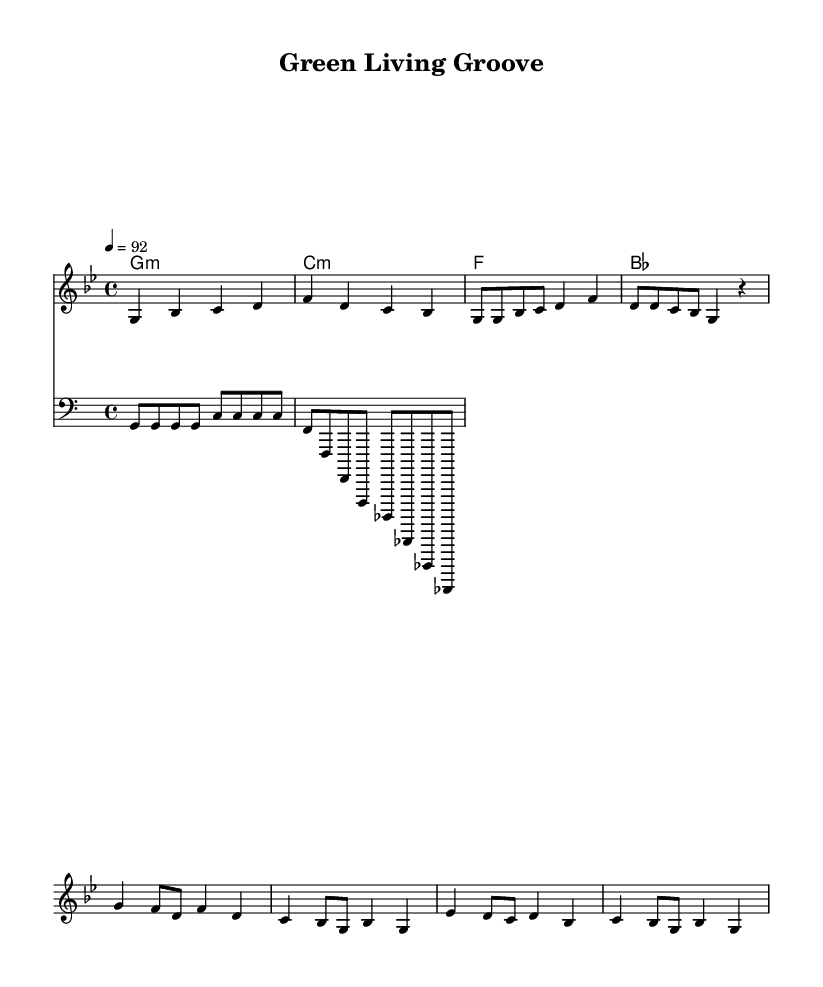What is the key signature of this music? The key signature of the piece is G minor, which includes two flats (B♭ and E♭). This can be identified from the global section of the code where the key is set.
Answer: G minor What is the time signature of this music? The time signature is 4/4, meaning there are four beats in a measure and the quarter note gets one beat. This is clearly stated in the global section of the code.
Answer: 4/4 What is the tempo marking for this piece? The tempo marking for the piece is 92 beats per minute, as indicated in the global section of the code. This specifies how fast the piece should be played.
Answer: 92 How many measures are in the verse section? The verse section consists of 4 measures, identifiable by counting the bars in the melody section designated for the verse.
Answer: 4 What type of instrument is indicated by the clef used in the bass line? The clef used in the bass line is a bass clef, which indicates that it is intended for lower-pitched instruments such as bass guitar or double bass. This is shown by the 'clef bass' declaration in the code.
Answer: Bass How many chords are represented in the chords section? There are 4 chords represented in the chord section, as counted from the harmony lines provided. Each chord corresponds to a measure.
Answer: 4 What is the main theme of the lyrics suggested by the title? The title "Green Living Groove" suggests a theme focused on eco-friendliness and sustainability, which is emphasized by the implications of 'groove' suggesting a rhythmic or engaging approach to these themes.
Answer: Eco-friendliness 